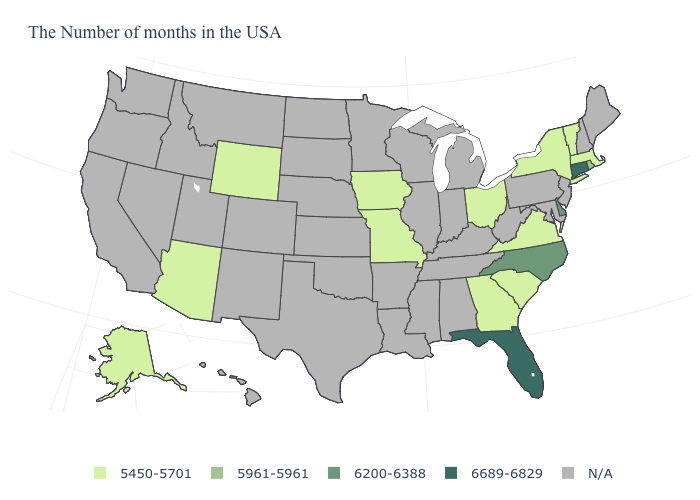Does the map have missing data?
Concise answer only. Yes. What is the value of Maine?
Keep it brief. N/A. What is the value of Georgia?
Give a very brief answer. 5450-5701. Does the first symbol in the legend represent the smallest category?
Give a very brief answer. Yes. Name the states that have a value in the range N/A?
Be succinct. Maine, New Hampshire, New Jersey, Maryland, Pennsylvania, West Virginia, Michigan, Kentucky, Indiana, Alabama, Tennessee, Wisconsin, Illinois, Mississippi, Louisiana, Arkansas, Minnesota, Kansas, Nebraska, Oklahoma, Texas, South Dakota, North Dakota, Colorado, New Mexico, Utah, Montana, Idaho, Nevada, California, Washington, Oregon, Hawaii. What is the lowest value in states that border New Jersey?
Keep it brief. 5450-5701. What is the value of Virginia?
Be succinct. 5450-5701. What is the value of Oklahoma?
Write a very short answer. N/A. What is the highest value in states that border Kentucky?
Concise answer only. 5450-5701. How many symbols are there in the legend?
Quick response, please. 5. What is the lowest value in the Northeast?
Quick response, please. 5450-5701. Among the states that border North Carolina , which have the lowest value?
Keep it brief. Virginia, South Carolina, Georgia. Name the states that have a value in the range N/A?
Write a very short answer. Maine, New Hampshire, New Jersey, Maryland, Pennsylvania, West Virginia, Michigan, Kentucky, Indiana, Alabama, Tennessee, Wisconsin, Illinois, Mississippi, Louisiana, Arkansas, Minnesota, Kansas, Nebraska, Oklahoma, Texas, South Dakota, North Dakota, Colorado, New Mexico, Utah, Montana, Idaho, Nevada, California, Washington, Oregon, Hawaii. Is the legend a continuous bar?
Be succinct. No. 